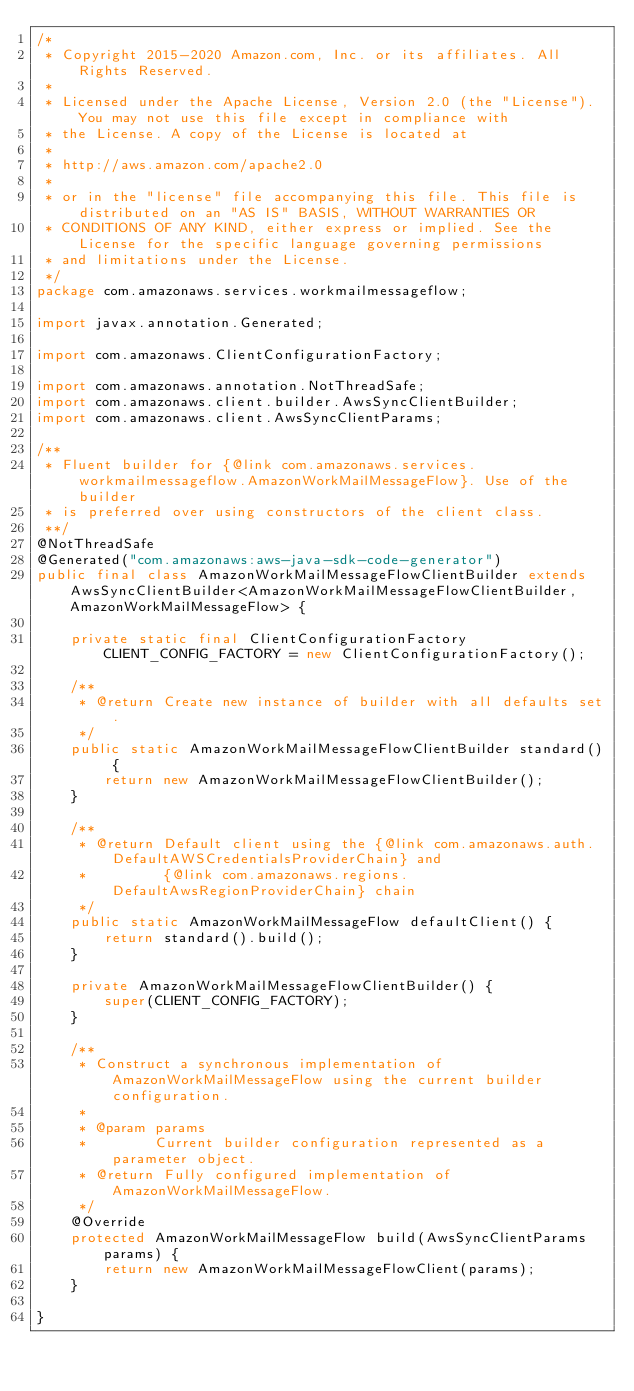<code> <loc_0><loc_0><loc_500><loc_500><_Java_>/*
 * Copyright 2015-2020 Amazon.com, Inc. or its affiliates. All Rights Reserved.
 * 
 * Licensed under the Apache License, Version 2.0 (the "License"). You may not use this file except in compliance with
 * the License. A copy of the License is located at
 * 
 * http://aws.amazon.com/apache2.0
 * 
 * or in the "license" file accompanying this file. This file is distributed on an "AS IS" BASIS, WITHOUT WARRANTIES OR
 * CONDITIONS OF ANY KIND, either express or implied. See the License for the specific language governing permissions
 * and limitations under the License.
 */
package com.amazonaws.services.workmailmessageflow;

import javax.annotation.Generated;

import com.amazonaws.ClientConfigurationFactory;

import com.amazonaws.annotation.NotThreadSafe;
import com.amazonaws.client.builder.AwsSyncClientBuilder;
import com.amazonaws.client.AwsSyncClientParams;

/**
 * Fluent builder for {@link com.amazonaws.services.workmailmessageflow.AmazonWorkMailMessageFlow}. Use of the builder
 * is preferred over using constructors of the client class.
 **/
@NotThreadSafe
@Generated("com.amazonaws:aws-java-sdk-code-generator")
public final class AmazonWorkMailMessageFlowClientBuilder extends AwsSyncClientBuilder<AmazonWorkMailMessageFlowClientBuilder, AmazonWorkMailMessageFlow> {

    private static final ClientConfigurationFactory CLIENT_CONFIG_FACTORY = new ClientConfigurationFactory();

    /**
     * @return Create new instance of builder with all defaults set.
     */
    public static AmazonWorkMailMessageFlowClientBuilder standard() {
        return new AmazonWorkMailMessageFlowClientBuilder();
    }

    /**
     * @return Default client using the {@link com.amazonaws.auth.DefaultAWSCredentialsProviderChain} and
     *         {@link com.amazonaws.regions.DefaultAwsRegionProviderChain} chain
     */
    public static AmazonWorkMailMessageFlow defaultClient() {
        return standard().build();
    }

    private AmazonWorkMailMessageFlowClientBuilder() {
        super(CLIENT_CONFIG_FACTORY);
    }

    /**
     * Construct a synchronous implementation of AmazonWorkMailMessageFlow using the current builder configuration.
     *
     * @param params
     *        Current builder configuration represented as a parameter object.
     * @return Fully configured implementation of AmazonWorkMailMessageFlow.
     */
    @Override
    protected AmazonWorkMailMessageFlow build(AwsSyncClientParams params) {
        return new AmazonWorkMailMessageFlowClient(params);
    }

}
</code> 